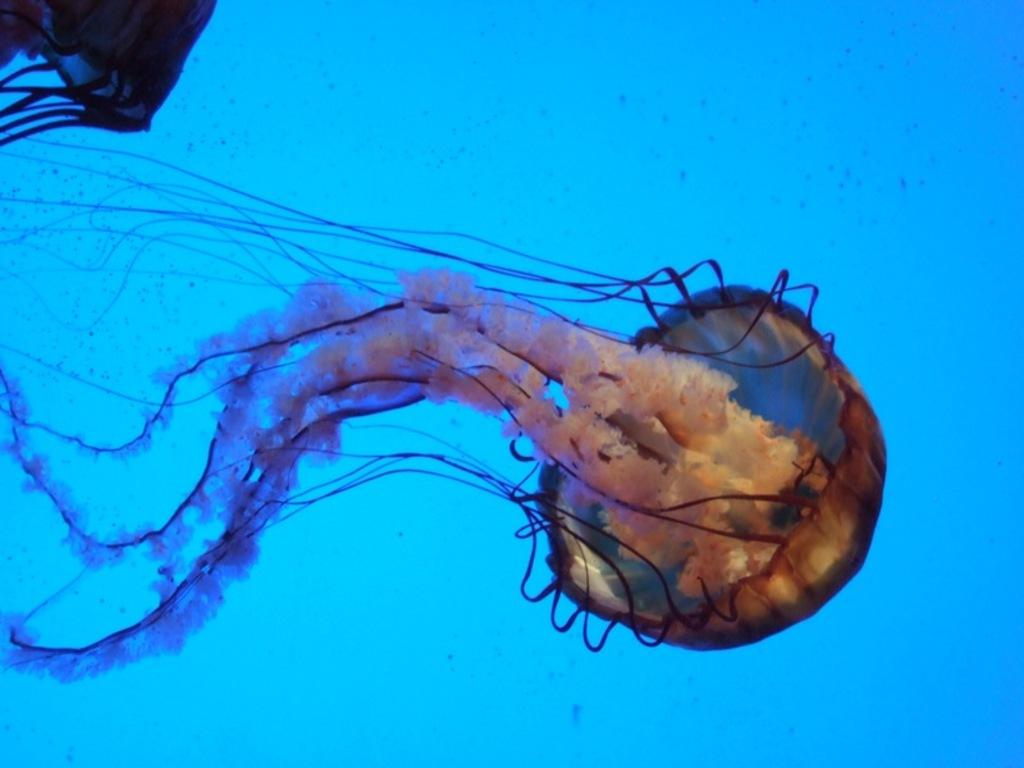What animals can be seen in the water in the image? There are two jellyfishes in the water in the image. Where is the water located? The water is in an ocean. What color is the background of the image? The background color is blue. How does the mother interact with the jellyfishes in the image? There is no mother or interaction with the jellyfishes present in the image. 